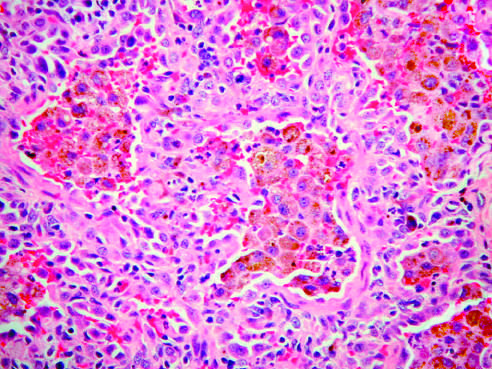what does the lung biopsy specimen demonstrate?
Answer the question using a single word or phrase. Large numbers of intraalveolar hemosiderin-laden macrophages 